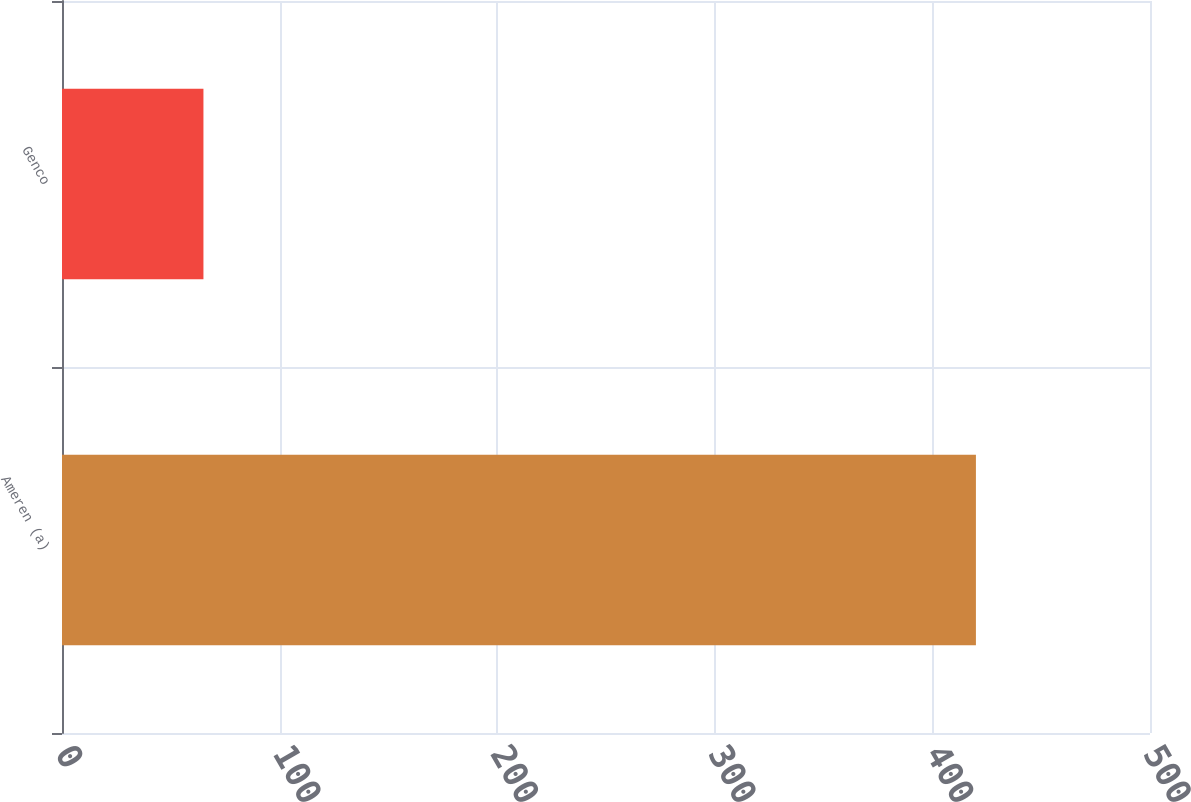<chart> <loc_0><loc_0><loc_500><loc_500><bar_chart><fcel>Ameren (a)<fcel>Genco<nl><fcel>420<fcel>65<nl></chart> 